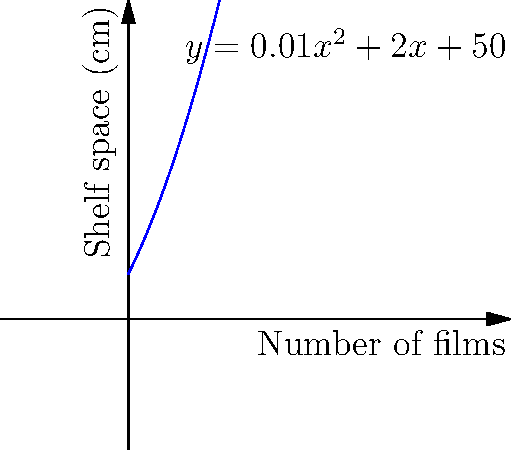As a rare film collector, you're optimizing your storage space. The relationship between the number of films (x) and required shelf space in centimeters (y) is modeled by the function $y = 0.01x^2 + 2x + 50$. If you have 300 cm of available shelf space, what is the maximum number of films you can store? To solve this problem, we need to follow these steps:

1) We're looking for the value of x (number of films) when y (shelf space) is 300 cm.
   So, we need to solve the equation: $300 = 0.01x^2 + 2x + 50$

2) Rearrange the equation:
   $0.01x^2 + 2x - 250 = 0$

3) This is a quadratic equation in the form $ax^2 + bx + c = 0$, where:
   $a = 0.01$, $b = 2$, and $c = -250$

4) We can solve this using the quadratic formula: $x = \frac{-b \pm \sqrt{b^2 - 4ac}}{2a}$

5) Substituting our values:
   $x = \frac{-2 \pm \sqrt{2^2 - 4(0.01)(-250)}}{2(0.01)}$

6) Simplify:
   $x = \frac{-2 \pm \sqrt{4 + 10}}{0.02} = \frac{-2 \pm \sqrt{14}}{0.02}$

7) Calculate:
   $x \approx 82.8$ or $x \approx -182.8$

8) Since we can't have a negative number of films, we take the positive solution.

9) The number of films must be a whole number, so we round down to 82.
Answer: 82 films 